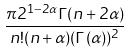Convert formula to latex. <formula><loc_0><loc_0><loc_500><loc_500>\frac { \pi 2 ^ { 1 - 2 \alpha } \Gamma ( n + 2 \alpha ) } { n ! ( n + \alpha ) ( \Gamma ( \alpha ) ) ^ { 2 } }</formula> 